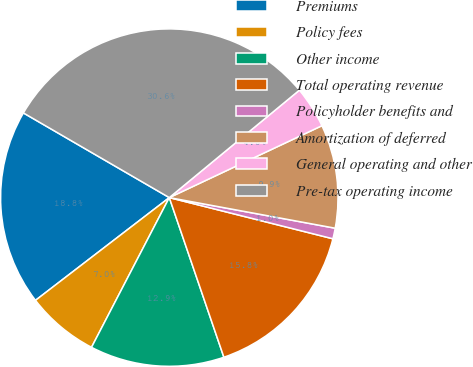<chart> <loc_0><loc_0><loc_500><loc_500><pie_chart><fcel>Premiums<fcel>Policy fees<fcel>Other income<fcel>Total operating revenue<fcel>Policyholder benefits and<fcel>Amortization of deferred<fcel>General operating and other<fcel>Pre-tax operating income<nl><fcel>18.79%<fcel>6.95%<fcel>12.87%<fcel>15.83%<fcel>1.02%<fcel>9.91%<fcel>3.98%<fcel>30.64%<nl></chart> 